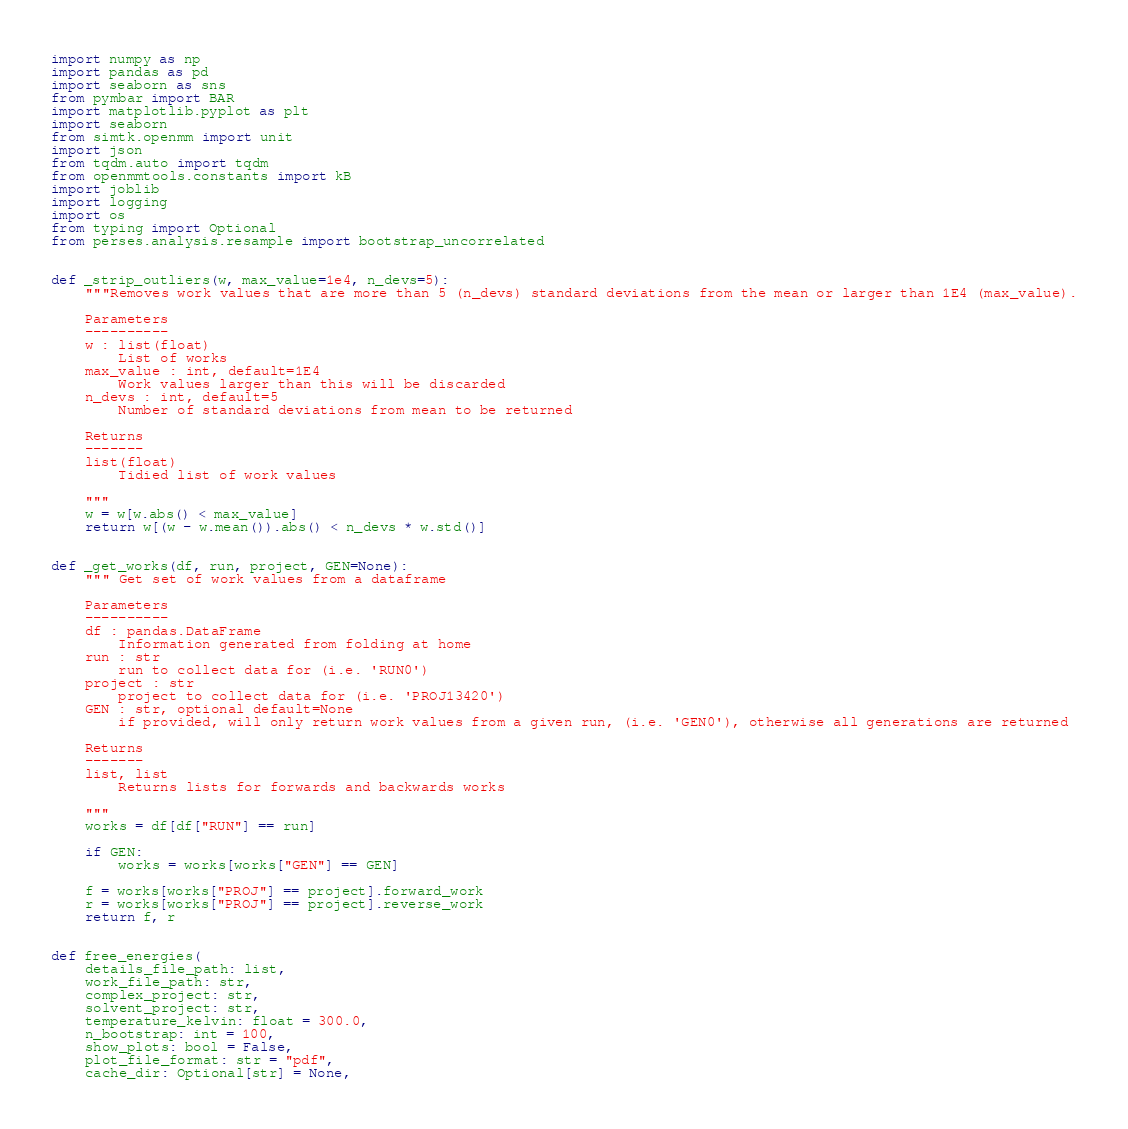Convert code to text. <code><loc_0><loc_0><loc_500><loc_500><_Python_>import numpy as np
import pandas as pd
import seaborn as sns
from pymbar import BAR
import matplotlib.pyplot as plt
import seaborn
from simtk.openmm import unit
import json
from tqdm.auto import tqdm
from openmmtools.constants import kB
import joblib
import logging
import os
from typing import Optional
from perses.analysis.resample import bootstrap_uncorrelated


def _strip_outliers(w, max_value=1e4, n_devs=5):
    """Removes work values that are more than 5 (n_devs) standard deviations from the mean or larger than 1E4 (max_value).

    Parameters
    ----------
    w : list(float)
        List of works
    max_value : int, default=1E4
        Work values larger than this will be discarded
    n_devs : int, default=5
        Number of standard deviations from mean to be returned

    Returns
    -------
    list(float)
        Tidied list of work values

    """
    w = w[w.abs() < max_value]
    return w[(w - w.mean()).abs() < n_devs * w.std()]


def _get_works(df, run, project, GEN=None):
    """ Get set of work values from a dataframe

    Parameters
    ----------
    df : pandas.DataFrame
        Information generated from folding at home
    run : str
        run to collect data for (i.e. 'RUN0')
    project : str
        project to collect data for (i.e. 'PROJ13420')
    GEN : str, optional default=None
        if provided, will only return work values from a given run, (i.e. 'GEN0'), otherwise all generations are returned

    Returns
    -------
    list, list
        Returns lists for forwards and backwards works

    """
    works = df[df["RUN"] == run]

    if GEN:
        works = works[works["GEN"] == GEN]

    f = works[works["PROJ"] == project].forward_work
    r = works[works["PROJ"] == project].reverse_work
    return f, r


def free_energies(
    details_file_path: list,
    work_file_path: str,
    complex_project: str,
    solvent_project: str,
    temperature_kelvin: float = 300.0,
    n_bootstrap: int = 100,
    show_plots: bool = False,
    plot_file_format: str = "pdf",
    cache_dir: Optional[str] = None,</code> 